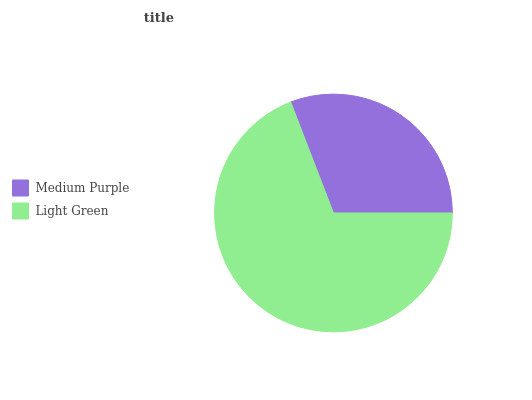Is Medium Purple the minimum?
Answer yes or no. Yes. Is Light Green the maximum?
Answer yes or no. Yes. Is Light Green the minimum?
Answer yes or no. No. Is Light Green greater than Medium Purple?
Answer yes or no. Yes. Is Medium Purple less than Light Green?
Answer yes or no. Yes. Is Medium Purple greater than Light Green?
Answer yes or no. No. Is Light Green less than Medium Purple?
Answer yes or no. No. Is Light Green the high median?
Answer yes or no. Yes. Is Medium Purple the low median?
Answer yes or no. Yes. Is Medium Purple the high median?
Answer yes or no. No. Is Light Green the low median?
Answer yes or no. No. 